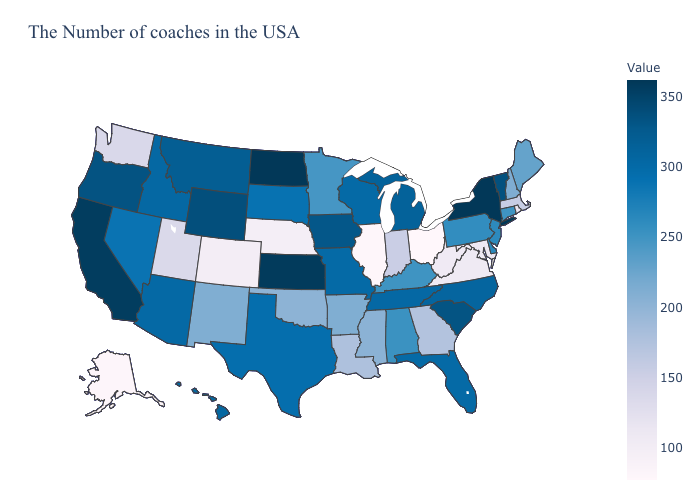Among the states that border Missouri , does Kansas have the highest value?
Write a very short answer. Yes. Does South Carolina have the highest value in the South?
Be succinct. Yes. Among the states that border Montana , does South Dakota have the lowest value?
Concise answer only. Yes. Which states hav the highest value in the Northeast?
Concise answer only. New York. Among the states that border Indiana , does Michigan have the highest value?
Give a very brief answer. Yes. 